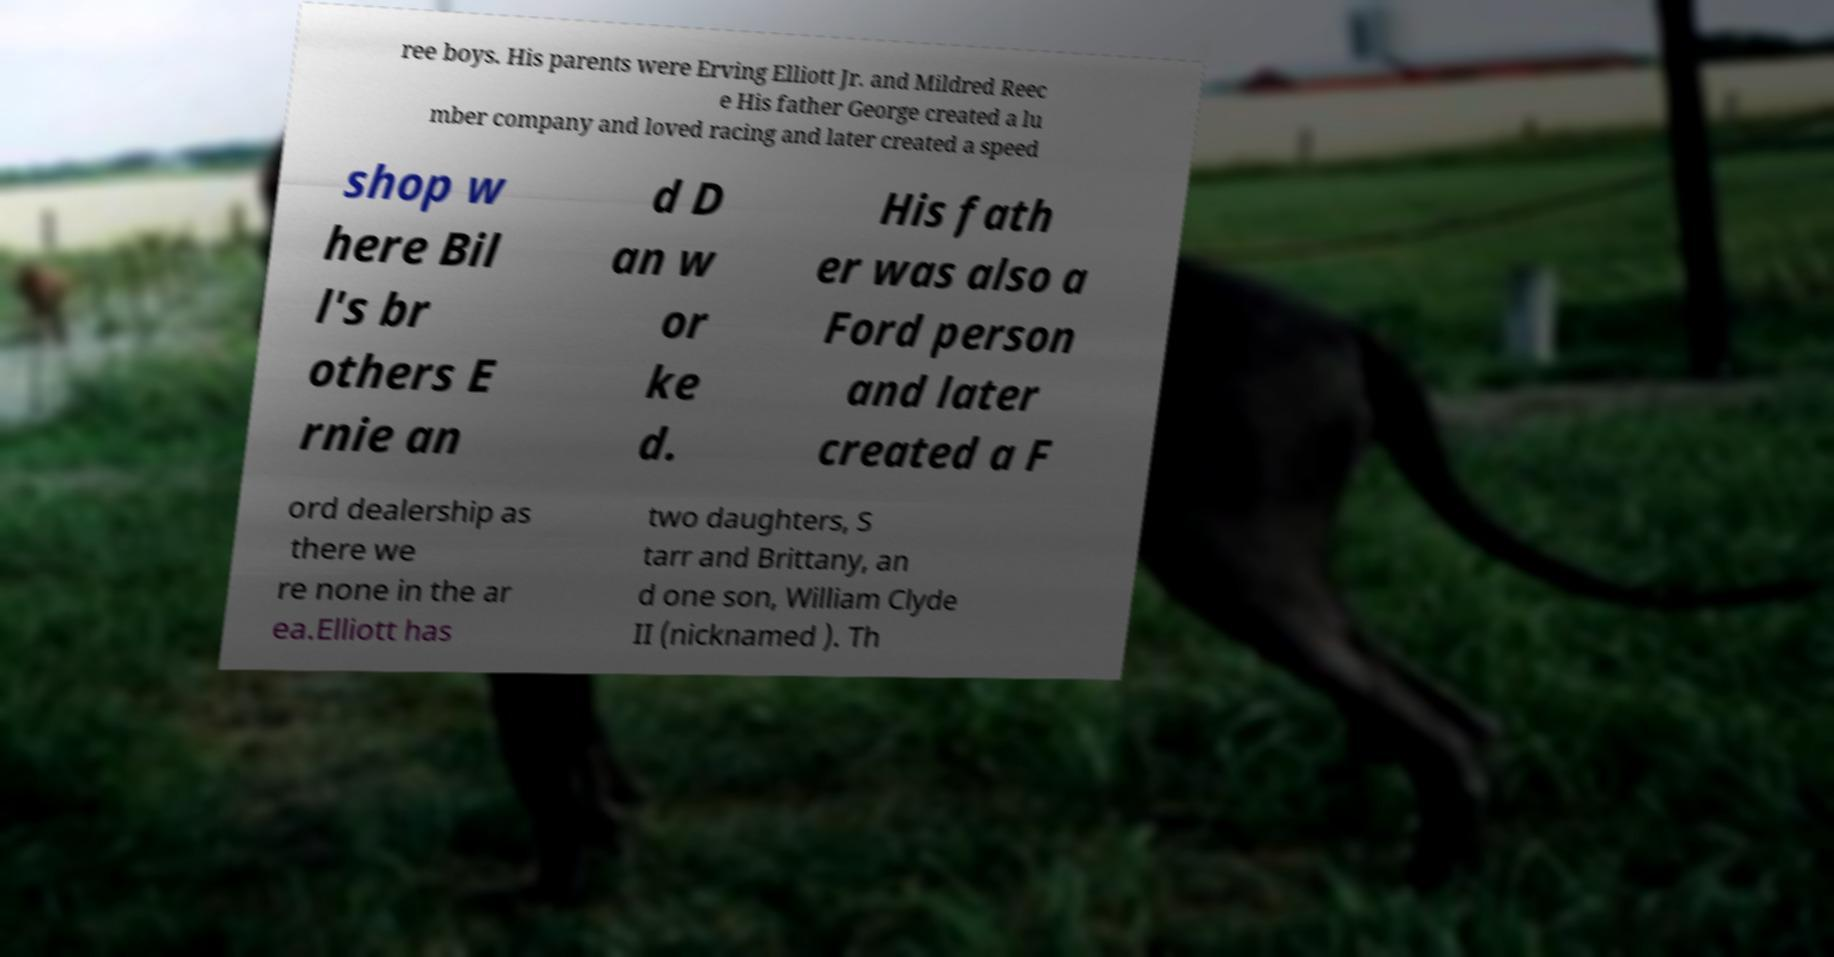Could you extract and type out the text from this image? ree boys. His parents were Erving Elliott Jr. and Mildred Reec e His father George created a lu mber company and loved racing and later created a speed shop w here Bil l's br others E rnie an d D an w or ke d. His fath er was also a Ford person and later created a F ord dealership as there we re none in the ar ea.Elliott has two daughters, S tarr and Brittany, an d one son, William Clyde II (nicknamed ). Th 